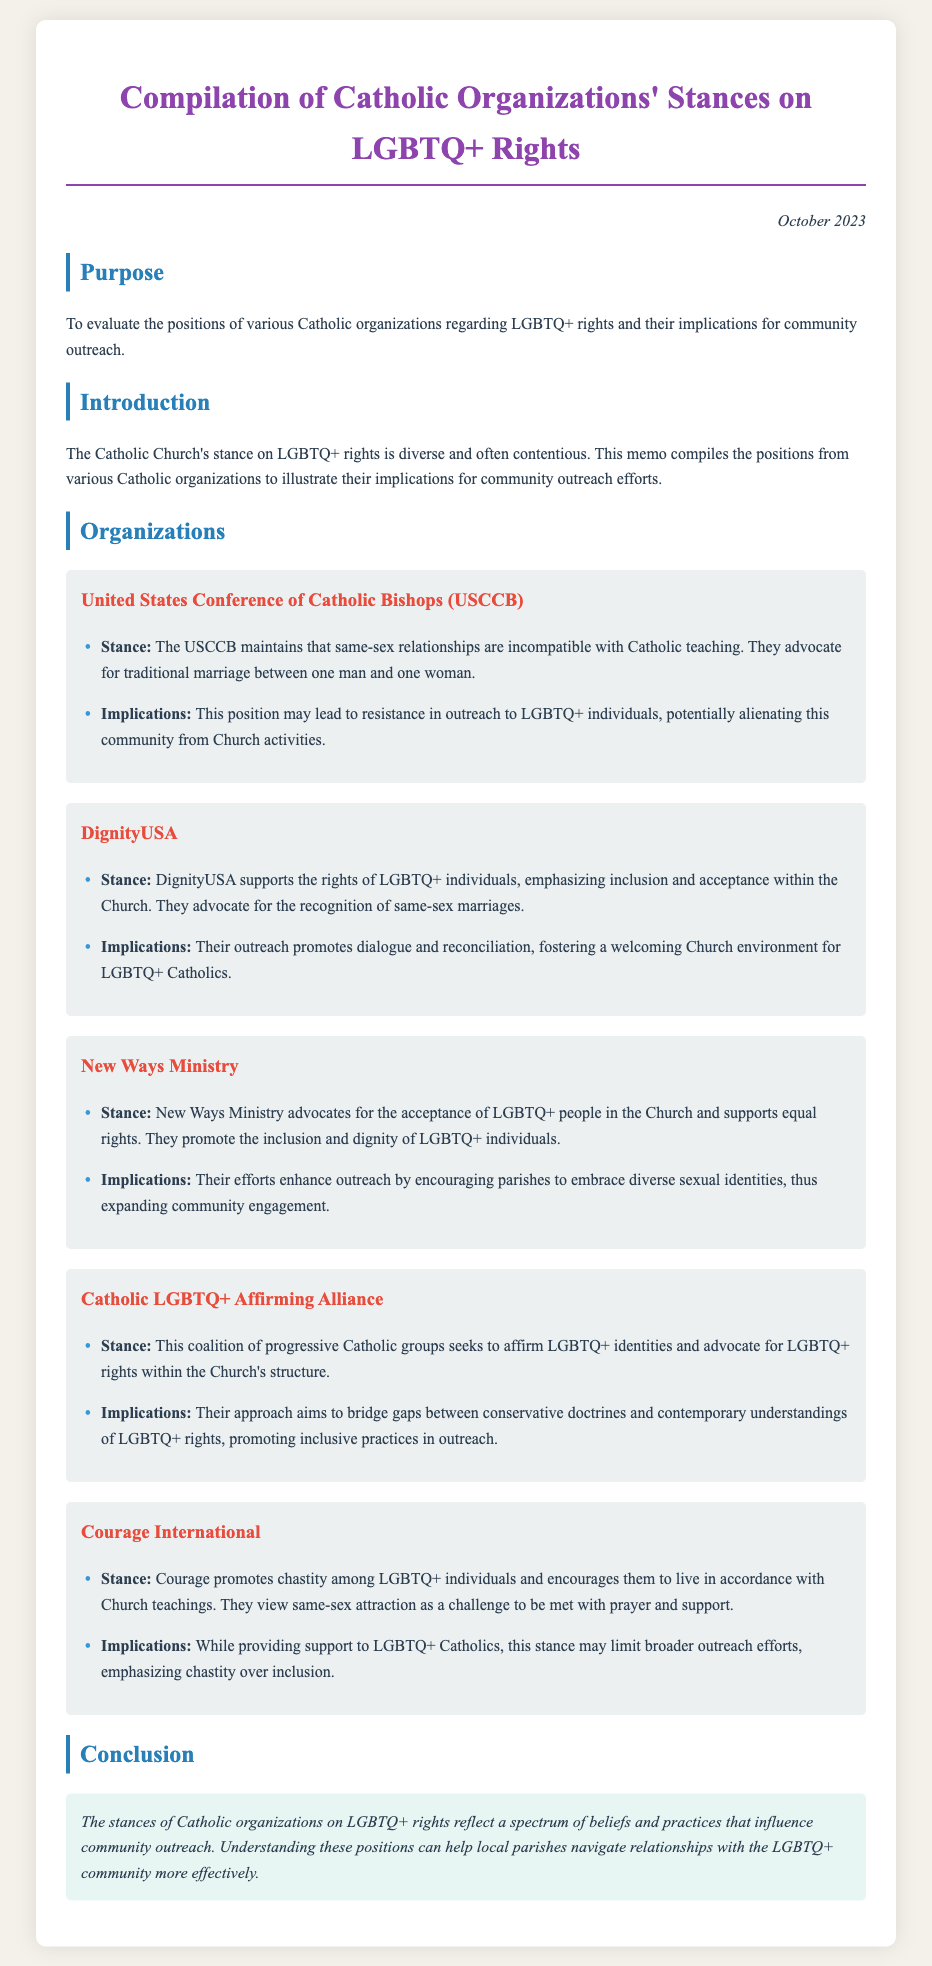What is the purpose of the memo? The purpose is outlined in the first section of the memo, which states it is to evaluate the positions of various Catholic organizations regarding LGBTQ+ rights and their implications for community outreach.
Answer: To evaluate the positions of various Catholic organizations regarding LGBTQ+ rights and their implications for community outreach When was the memo written? The date is mentioned at the top of the memo, indicating when it was created.
Answer: October 2023 What stance does DignityUSA take on LGBTQ+ rights? The document specifies DignityUSA's stance on LGBTQ+ rights, emphasizing inclusion and acceptance.
Answer: Supports the rights of LGBTQ+ individuals, emphasizing inclusion and acceptance What is the implication of the USCCB's stance on community outreach? The implication is described in the USCCB section about how their stance may affect outreach to the LGBTQ+ community.
Answer: This position may lead to resistance in outreach to LGBTQ+ individuals Which organization advocates for the acceptance of LGBTQ+ people? The document clearly states which organization focuses on advocacy for LGBTQ+ acceptance in the Church.
Answer: New Ways Ministry How does Courage International's stance affect outreach efforts? The implications of Courage's stance highlight how it impacts their outreach approach.
Answer: This stance may limit broader outreach efforts What is the overall conclusion about Catholic organizations' stances? The conclusion summarizes the effect of diverse beliefs on community outreach, as mentioned in the conclusion section.
Answer: Reflect a spectrum of beliefs and practices that influence community outreach What does the Catholic LGBTQ+ Affirming Alliance aim to do? The document details the mission of the Catholic LGBTQ+ Affirming Alliance regarding LGBTQ+ rights in the Church.
Answer: Seeks to affirm LGBTQ+ identities and advocate for LGBTQ+ rights within the Church's structure 